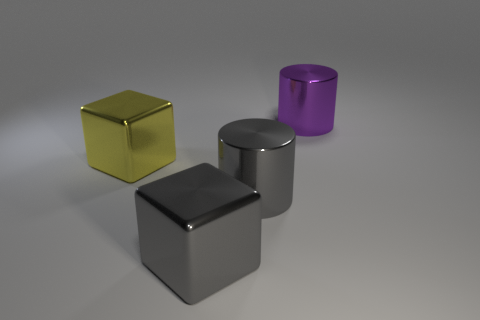Add 1 big metallic things. How many objects exist? 5 Subtract 1 cubes. How many cubes are left? 1 Add 3 big purple things. How many big purple things are left? 4 Add 1 tiny brown metal balls. How many tiny brown metal balls exist? 1 Subtract 0 cyan cubes. How many objects are left? 4 Subtract all cyan blocks. Subtract all gray spheres. How many blocks are left? 2 Subtract all gray cubes. How many green cylinders are left? 0 Subtract all big blue shiny cylinders. Subtract all gray cylinders. How many objects are left? 3 